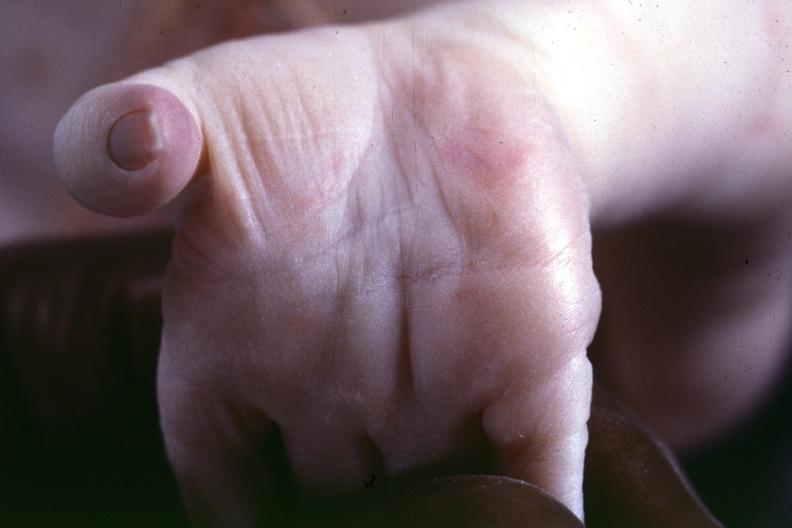what is previous slide from this case suspect?
Answer the question using a single word or phrase. A simian crease 